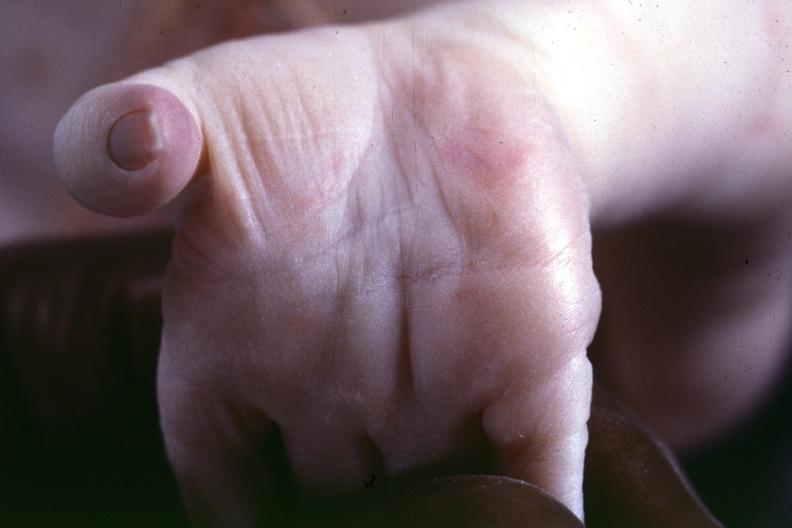what is previous slide from this case suspect?
Answer the question using a single word or phrase. A simian crease 